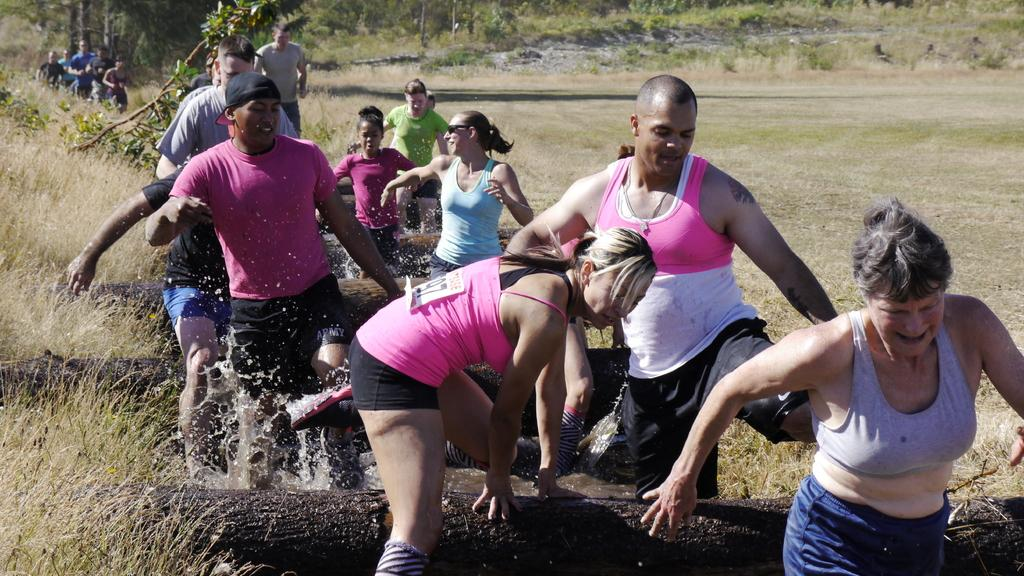Who or what can be seen in the image? There are people in the image. What is the primary element visible in the image? There is water visible in the image. What object is present in the image? There is a log of wood in the image. What type of vegetation is in the image? There are plants in the image. What type of government is depicted in the image? There is no depiction of a government in the image; it features people, water, a log of wood, and plants. How does the image convey a sense of disgust? The image does not convey a sense of disgust; it is a neutral representation of people, water, a log of wood, and plants. 